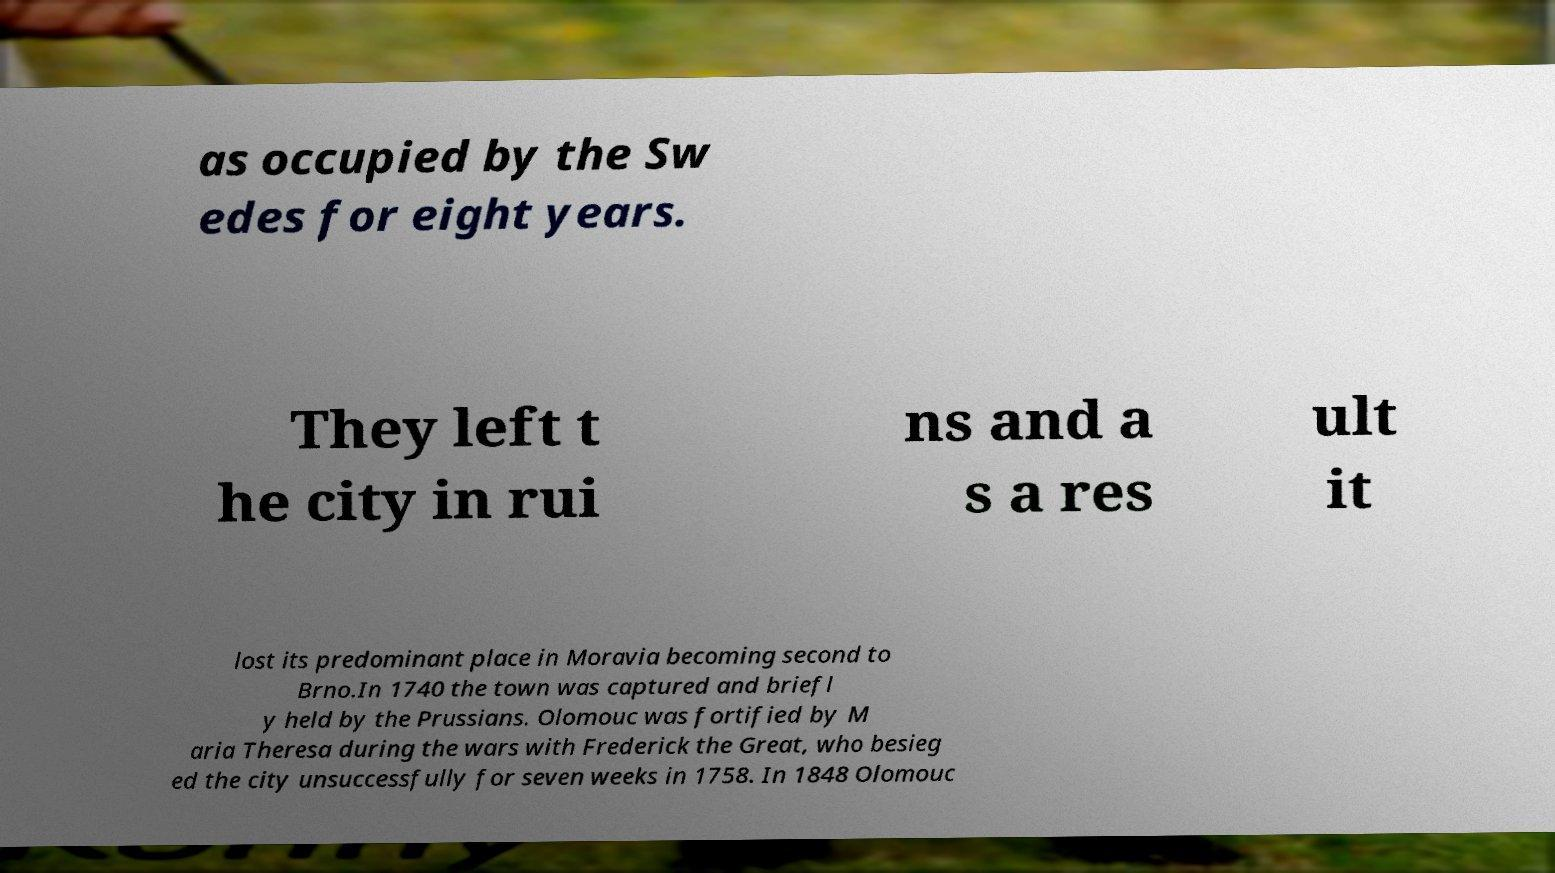What messages or text are displayed in this image? I need them in a readable, typed format. as occupied by the Sw edes for eight years. They left t he city in rui ns and a s a res ult it lost its predominant place in Moravia becoming second to Brno.In 1740 the town was captured and briefl y held by the Prussians. Olomouc was fortified by M aria Theresa during the wars with Frederick the Great, who besieg ed the city unsuccessfully for seven weeks in 1758. In 1848 Olomouc 